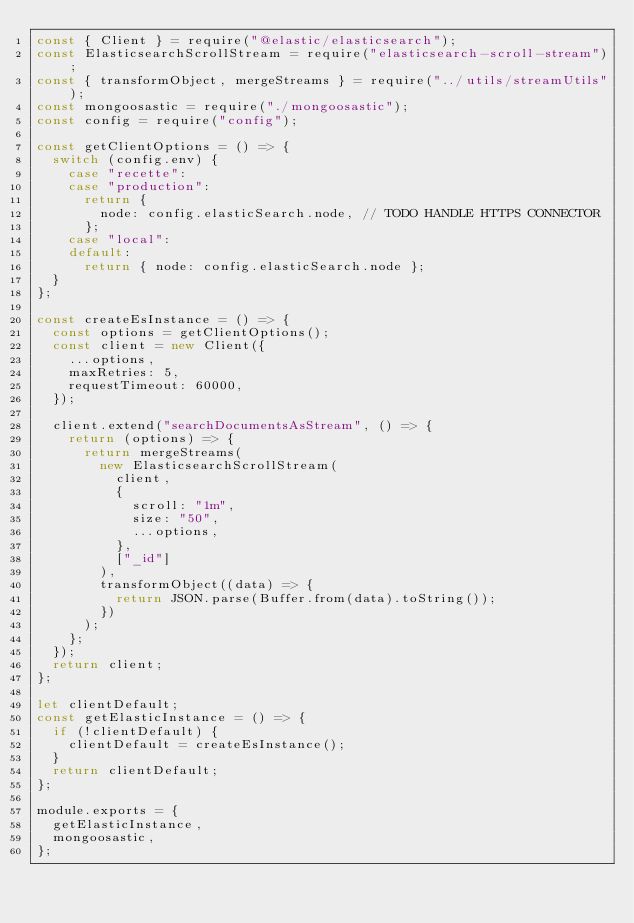Convert code to text. <code><loc_0><loc_0><loc_500><loc_500><_JavaScript_>const { Client } = require("@elastic/elasticsearch");
const ElasticsearchScrollStream = require("elasticsearch-scroll-stream");
const { transformObject, mergeStreams } = require("../utils/streamUtils");
const mongoosastic = require("./mongoosastic");
const config = require("config");

const getClientOptions = () => {
  switch (config.env) {
    case "recette":
    case "production":
      return {
        node: config.elasticSearch.node, // TODO HANDLE HTTPS CONNECTOR
      };
    case "local":
    default:
      return { node: config.elasticSearch.node };
  }
};

const createEsInstance = () => {
  const options = getClientOptions();
  const client = new Client({
    ...options,
    maxRetries: 5,
    requestTimeout: 60000,
  });

  client.extend("searchDocumentsAsStream", () => {
    return (options) => {
      return mergeStreams(
        new ElasticsearchScrollStream(
          client,
          {
            scroll: "1m",
            size: "50",
            ...options,
          },
          ["_id"]
        ),
        transformObject((data) => {
          return JSON.parse(Buffer.from(data).toString());
        })
      );
    };
  });
  return client;
};

let clientDefault;
const getElasticInstance = () => {
  if (!clientDefault) {
    clientDefault = createEsInstance();
  }
  return clientDefault;
};

module.exports = {
  getElasticInstance,
  mongoosastic,
};
</code> 